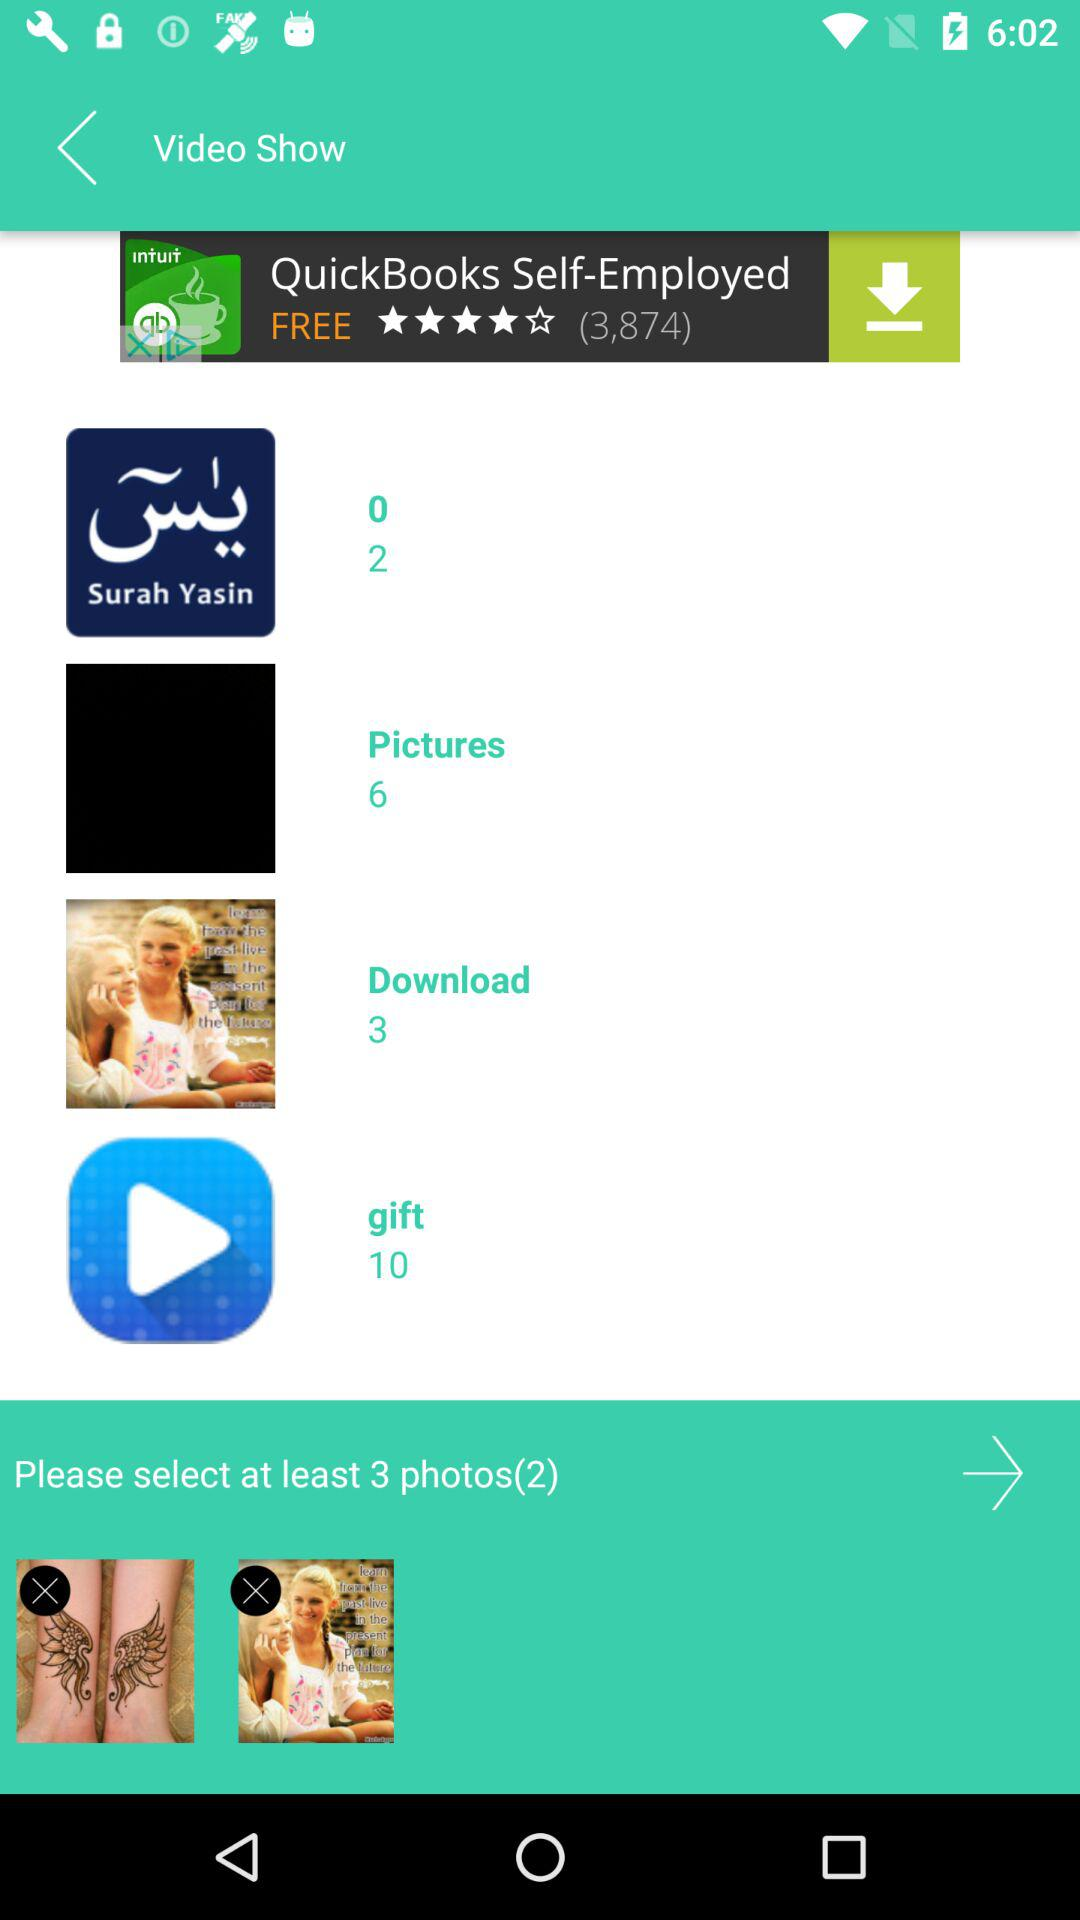What is the number of images in the "gift" album? There are 10 images in the "gift" album. 